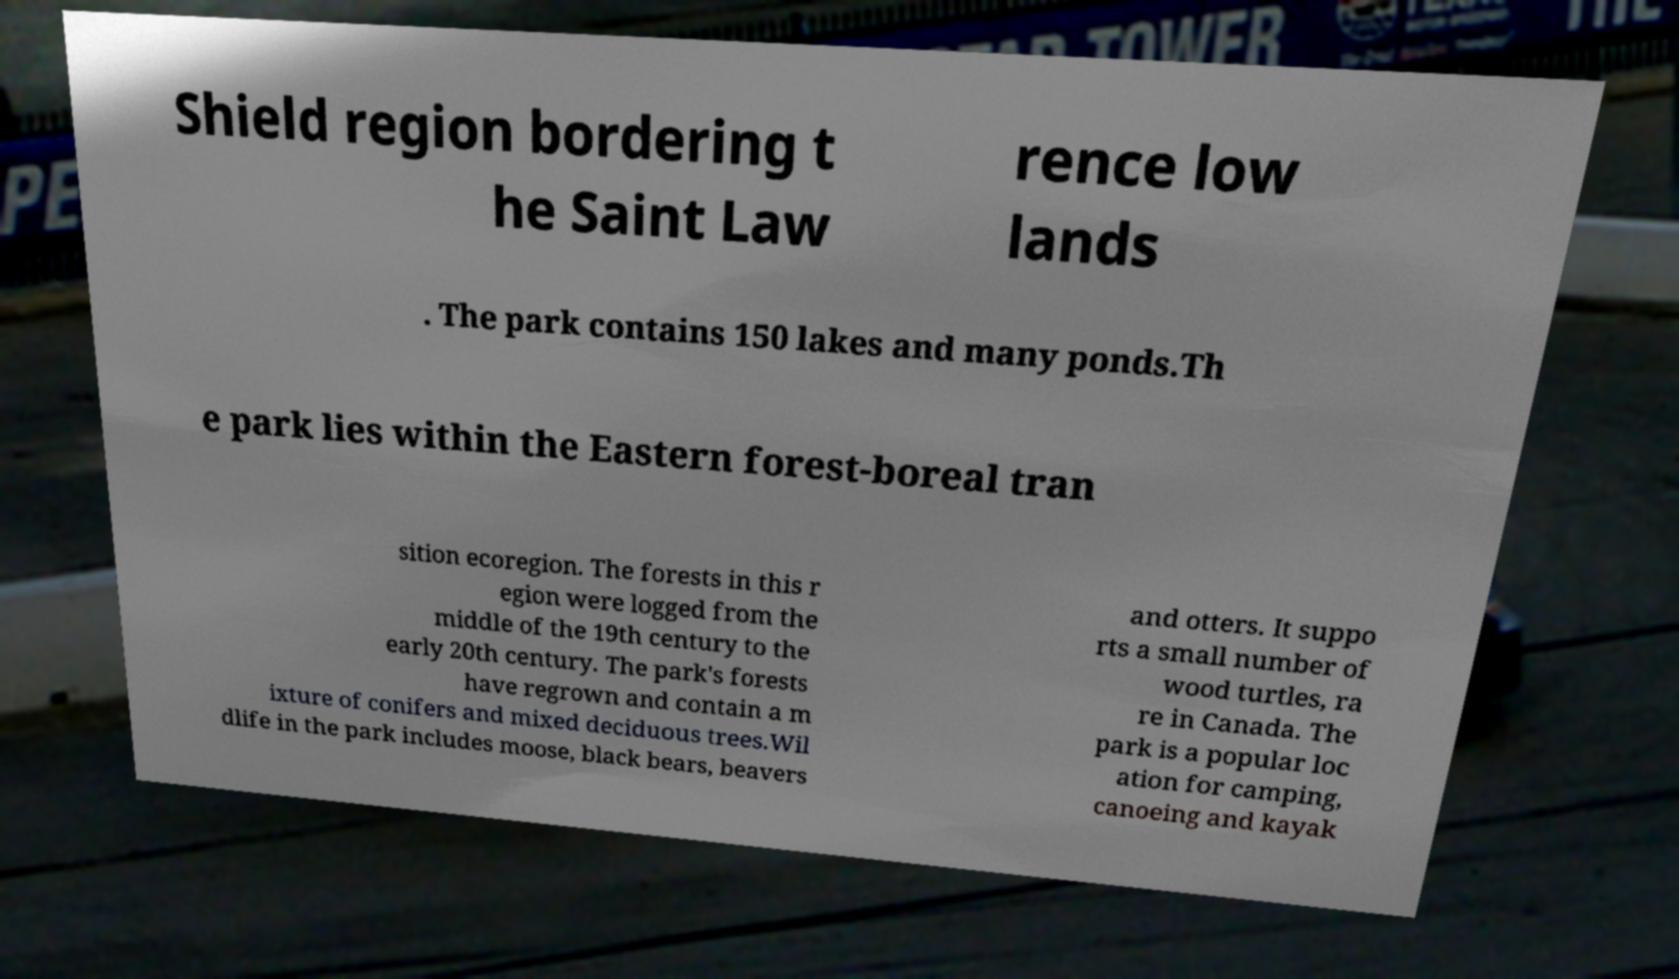For documentation purposes, I need the text within this image transcribed. Could you provide that? Shield region bordering t he Saint Law rence low lands . The park contains 150 lakes and many ponds.Th e park lies within the Eastern forest-boreal tran sition ecoregion. The forests in this r egion were logged from the middle of the 19th century to the early 20th century. The park's forests have regrown and contain a m ixture of conifers and mixed deciduous trees.Wil dlife in the park includes moose, black bears, beavers and otters. It suppo rts a small number of wood turtles, ra re in Canada. The park is a popular loc ation for camping, canoeing and kayak 